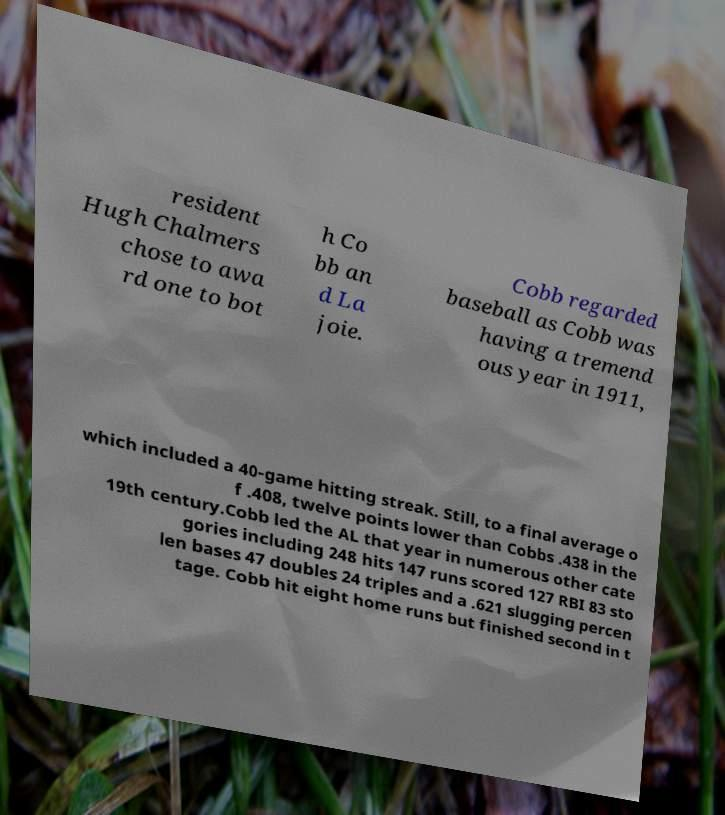Could you extract and type out the text from this image? resident Hugh Chalmers chose to awa rd one to bot h Co bb an d La joie. Cobb regarded baseball as Cobb was having a tremend ous year in 1911, which included a 40-game hitting streak. Still, to a final average o f .408, twelve points lower than Cobbs .438 in the 19th century.Cobb led the AL that year in numerous other cate gories including 248 hits 147 runs scored 127 RBI 83 sto len bases 47 doubles 24 triples and a .621 slugging percen tage. Cobb hit eight home runs but finished second in t 